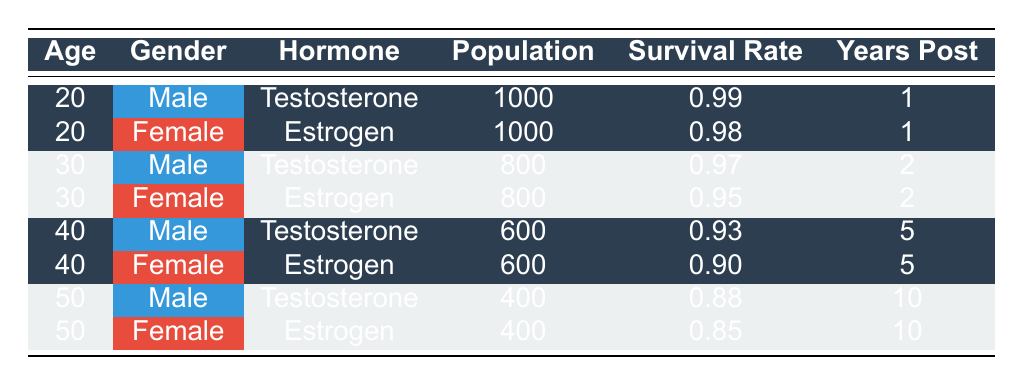What is the survival rate of males aged 20 undergoing testosterone optimization? From the table, we can see the row corresponding to males aged 20 with testosterone optimization. The survival rate listed in that row is 0.99.
Answer: 0.99 What is the population of females aged 30 undergoing estrogen optimization? We look at the row for females aged 30 with estrogen optimization, where the population is listed as 800.
Answer: 800 What is the difference in survival rates between males and females aged 40 undergoing hormone optimization? For males aged 40 with testosterone, the survival rate is 0.93. For females aged 40 with estrogen, the survival rate is 0.90. The difference is 0.93 - 0.90 = 0.03.
Answer: 0.03 Is the survival rate of males undergoing testosterone optimization higher at age 50 compared to age 40? The survival rate for males at age 50 is 0.88 and for age 40 is 0.93. Since 0.88 is less than 0.93, the statement is false.
Answer: No What is the average survival rate of the female population undergoing estrogen optimization across all age groups listed? The survival rates for females are 0.98 (age 20), 0.95 (age 30), 0.90 (age 40), and 0.85 (age 50). Adding these gives 0.98 + 0.95 + 0.90 + 0.85 = 3.68. Dividing by the number of age groups (4) gives an average of 3.68 / 4 = 0.92.
Answer: 0.92 Are there more males or females in the population aged 50? The population of males aged 50 is 400 and for females aged 50 is also 400. Since both values are equal, there is no difference.
Answer: No What is the survival rate of females aged 40 compared to that of males aged 30? The survival rate for females aged 40 is 0.90 and for males aged 30 it is 0.97. Since 0.90 is less than 0.97, the rate for females is lower.
Answer: Lower What is the total population of athletes who underwent hormone optimization at age 30? The total population of athletes at age 30 is the sum of males and females: 800 (males) + 800 (females) = 1600.
Answer: 1600 